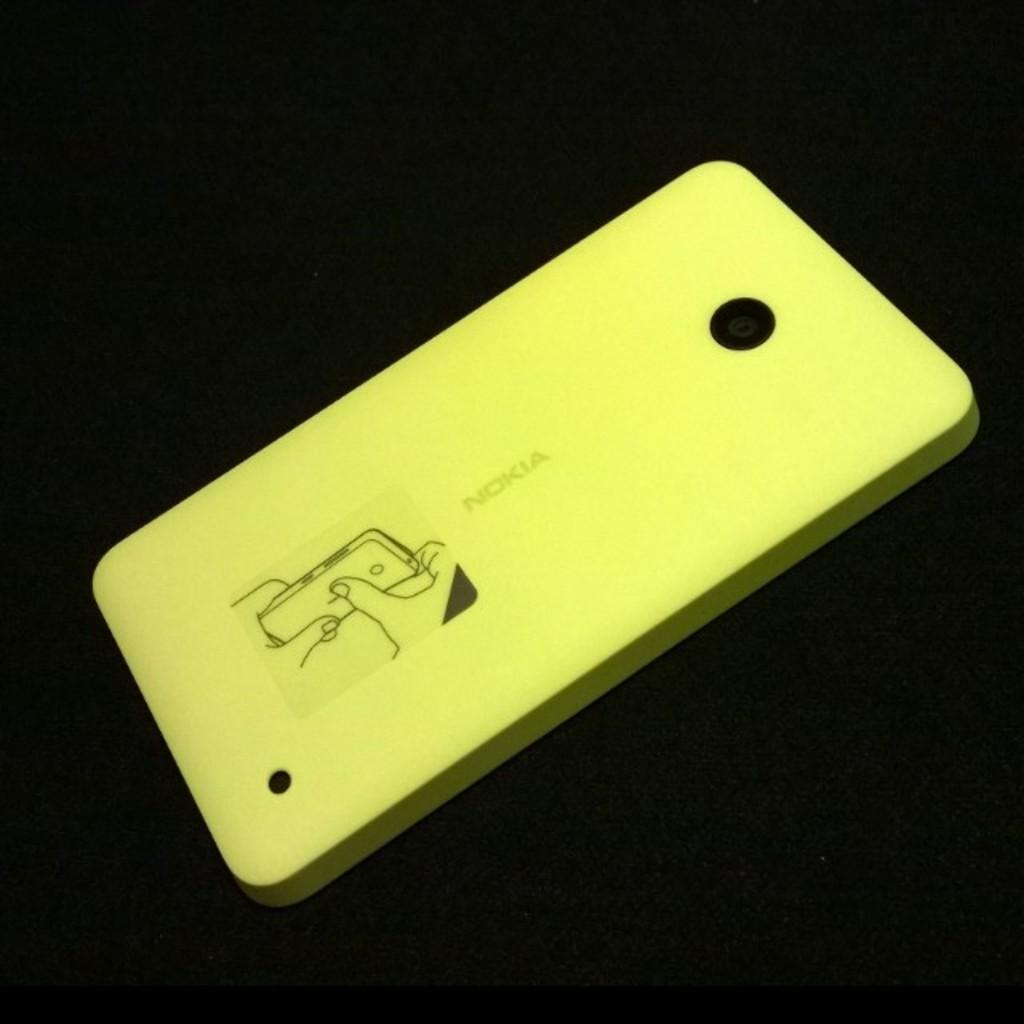<image>
Describe the image concisely. The back of a Nokia phone which features a diagram of how to open it. 